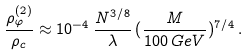Convert formula to latex. <formula><loc_0><loc_0><loc_500><loc_500>\frac { \rho _ { \varphi } ^ { ( 2 ) } } { \rho _ { c } } \approx 1 0 ^ { - 4 } \, \frac { N ^ { 3 / 8 } } { \lambda } \, ( \frac { M } { 1 0 0 \, G e V } ) ^ { 7 / 4 } \, .</formula> 